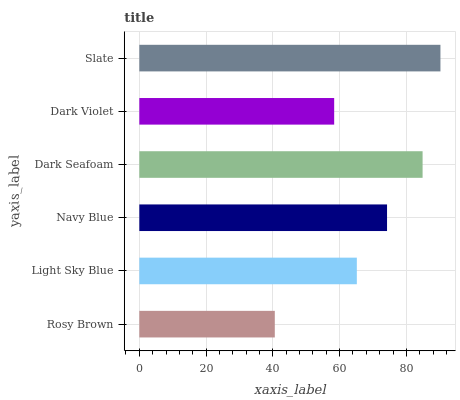Is Rosy Brown the minimum?
Answer yes or no. Yes. Is Slate the maximum?
Answer yes or no. Yes. Is Light Sky Blue the minimum?
Answer yes or no. No. Is Light Sky Blue the maximum?
Answer yes or no. No. Is Light Sky Blue greater than Rosy Brown?
Answer yes or no. Yes. Is Rosy Brown less than Light Sky Blue?
Answer yes or no. Yes. Is Rosy Brown greater than Light Sky Blue?
Answer yes or no. No. Is Light Sky Blue less than Rosy Brown?
Answer yes or no. No. Is Navy Blue the high median?
Answer yes or no. Yes. Is Light Sky Blue the low median?
Answer yes or no. Yes. Is Rosy Brown the high median?
Answer yes or no. No. Is Rosy Brown the low median?
Answer yes or no. No. 